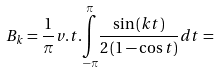<formula> <loc_0><loc_0><loc_500><loc_500>B _ { k } = \frac { 1 } { \pi } v . t . \underset { - \pi } { \overset { \pi } { \int } } \frac { \sin \left ( k t \right ) } { 2 \left ( 1 - \cos t \right ) } d t =</formula> 